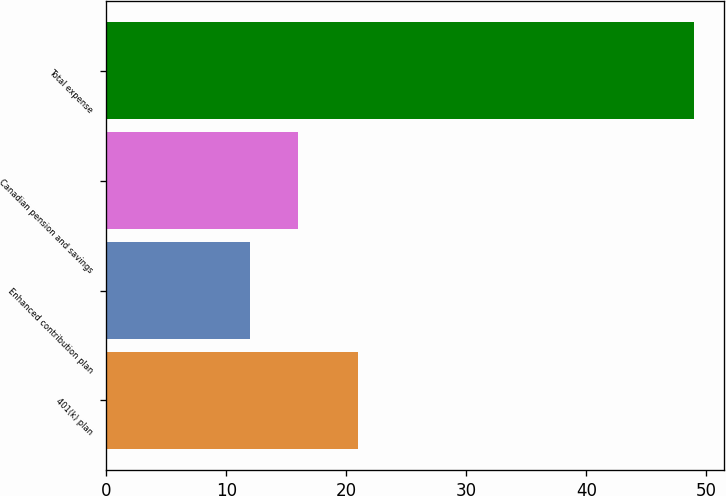<chart> <loc_0><loc_0><loc_500><loc_500><bar_chart><fcel>401(k) plan<fcel>Enhanced contribution plan<fcel>Canadian pension and savings<fcel>Total expense<nl><fcel>21<fcel>12<fcel>16<fcel>49<nl></chart> 